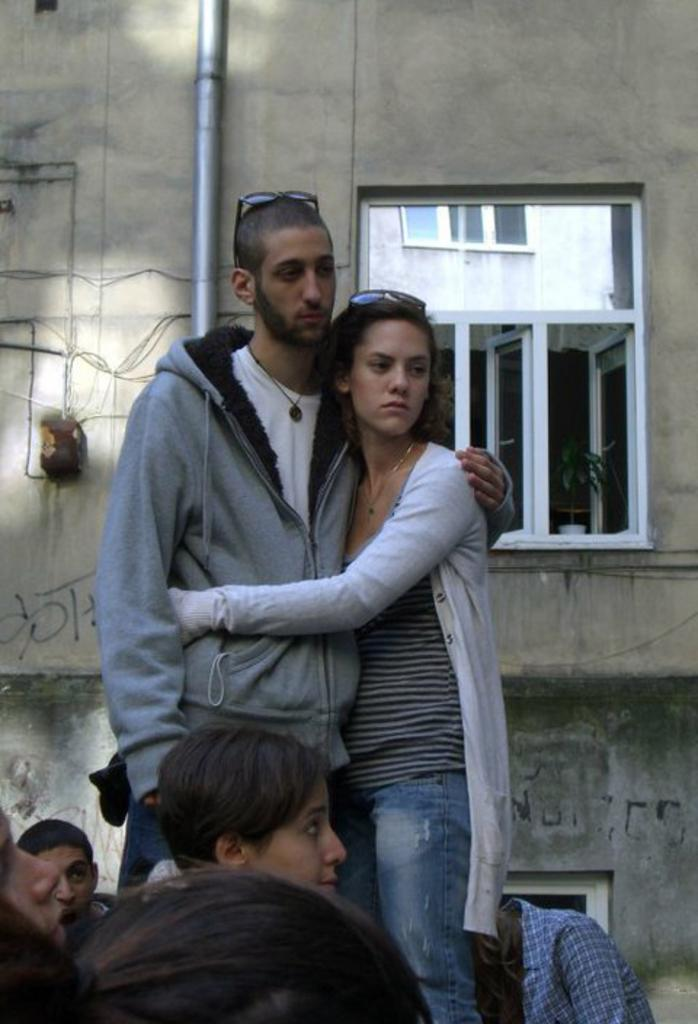What are the two persons in the image doing? The two persons in the image are standing and hugging each other. Can you describe the group of people in the image? There is a group of people in the image, but the conversation does not specify their actions or relationships. What type of structure is visible in the image? There is a building in the image. What architectural feature can be seen in the image? There is a window in the image. What object is present in the image that is not related to the people or the building? There is a pipe in the image. What type of plant is visible in the image? There is a plant in the image. Where is the crown located in the image? There is no crown present in the image. What type of church can be seen in the background of the image? There is no church present in the image. 